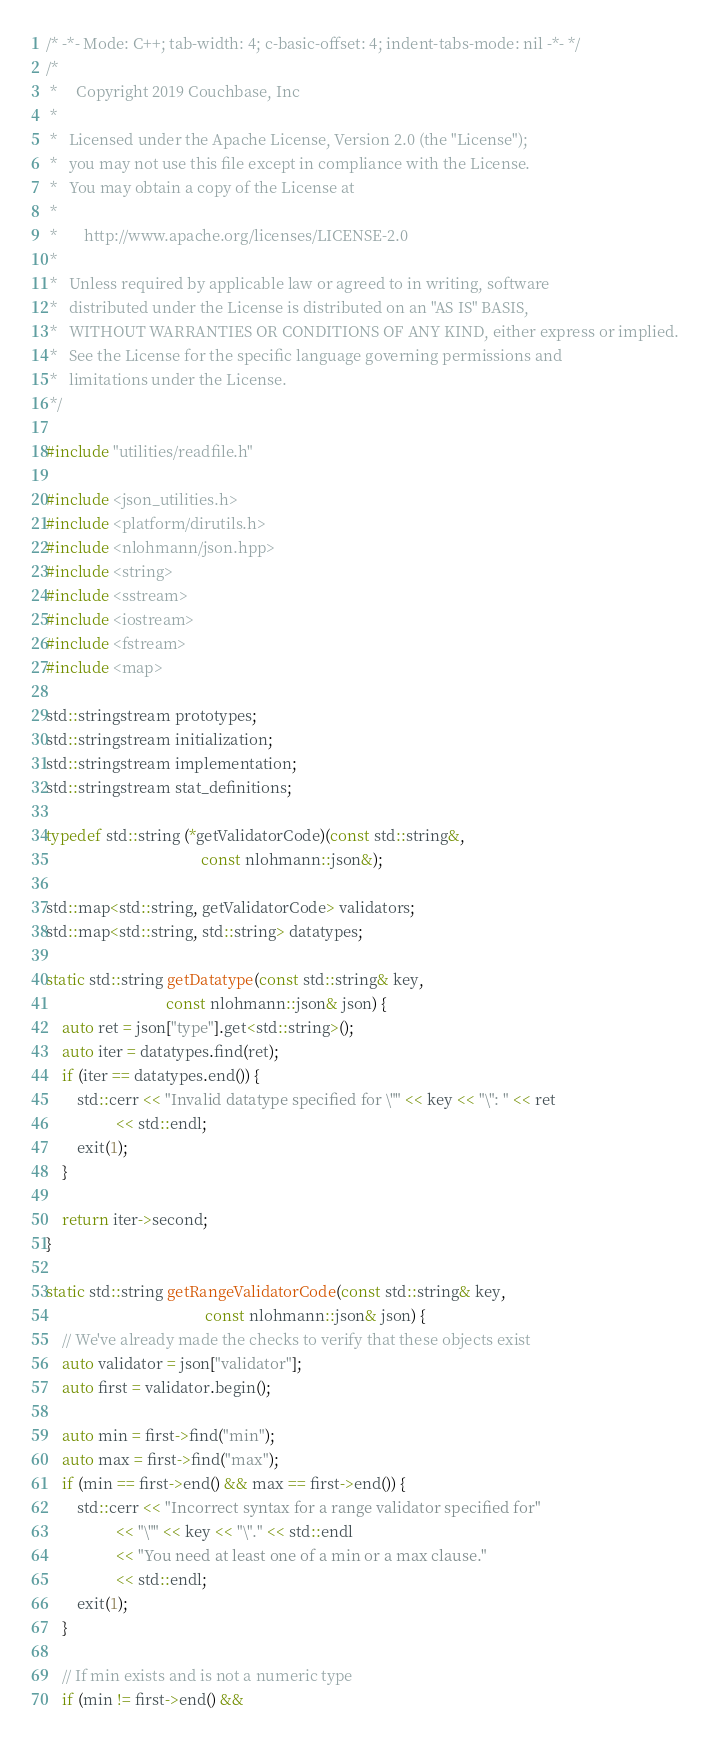Convert code to text. <code><loc_0><loc_0><loc_500><loc_500><_C++_>/* -*- Mode: C++; tab-width: 4; c-basic-offset: 4; indent-tabs-mode: nil -*- */
/*
 *     Copyright 2019 Couchbase, Inc
 *
 *   Licensed under the Apache License, Version 2.0 (the "License");
 *   you may not use this file except in compliance with the License.
 *   You may obtain a copy of the License at
 *
 *       http://www.apache.org/licenses/LICENSE-2.0
 *
 *   Unless required by applicable law or agreed to in writing, software
 *   distributed under the License is distributed on an "AS IS" BASIS,
 *   WITHOUT WARRANTIES OR CONDITIONS OF ANY KIND, either express or implied.
 *   See the License for the specific language governing permissions and
 *   limitations under the License.
 */

#include "utilities/readfile.h"

#include <json_utilities.h>
#include <platform/dirutils.h>
#include <nlohmann/json.hpp>
#include <string>
#include <sstream>
#include <iostream>
#include <fstream>
#include <map>

std::stringstream prototypes;
std::stringstream initialization;
std::stringstream implementation;
std::stringstream stat_definitions;

typedef std::string (*getValidatorCode)(const std::string&,
                                        const nlohmann::json&);

std::map<std::string, getValidatorCode> validators;
std::map<std::string, std::string> datatypes;

static std::string getDatatype(const std::string& key,
                               const nlohmann::json& json) {
    auto ret = json["type"].get<std::string>();
    auto iter = datatypes.find(ret);
    if (iter == datatypes.end()) {
        std::cerr << "Invalid datatype specified for \"" << key << "\": " << ret
                  << std::endl;
        exit(1);
    }

    return iter->second;
}

static std::string getRangeValidatorCode(const std::string& key,
                                         const nlohmann::json& json) {
    // We've already made the checks to verify that these objects exist
    auto validator = json["validator"];
    auto first = validator.begin();

    auto min = first->find("min");
    auto max = first->find("max");
    if (min == first->end() && max == first->end()) {
        std::cerr << "Incorrect syntax for a range validator specified for"
                  << "\"" << key << "\"." << std::endl
                  << "You need at least one of a min or a max clause."
                  << std::endl;
        exit(1);
    }

    // If min exists and is not a numeric type
    if (min != first->end() &&</code> 